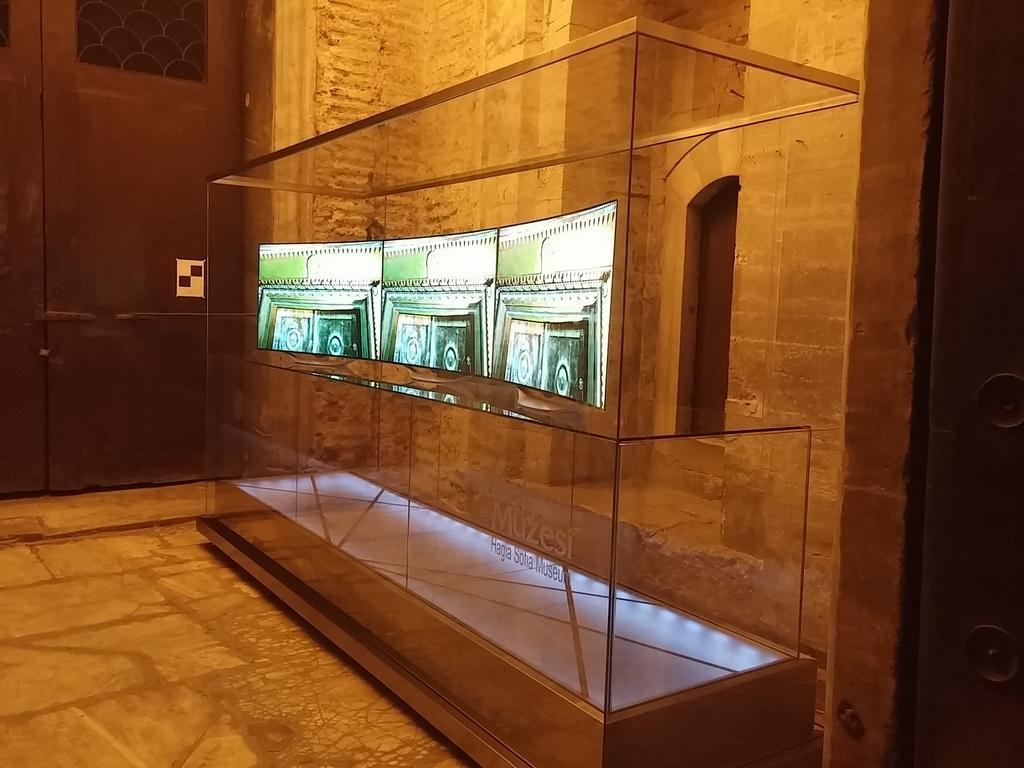Could you give a brief overview of what you see in this image? In this image, we can see a glass object with a screen and some text. We can see the ground and the wall with some object. We can also see the doors. 